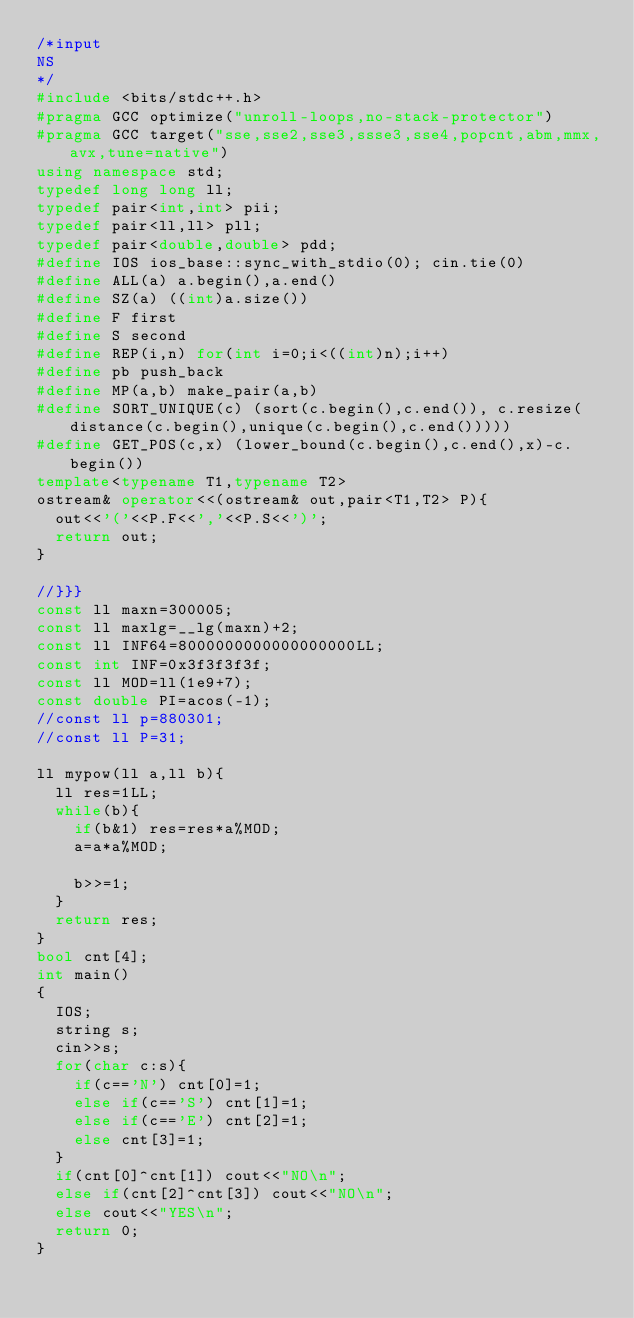Convert code to text. <code><loc_0><loc_0><loc_500><loc_500><_C++_>/*input
NS
*/
#include <bits/stdc++.h>
#pragma GCC optimize("unroll-loops,no-stack-protector")
#pragma GCC target("sse,sse2,sse3,ssse3,sse4,popcnt,abm,mmx,avx,tune=native")
using namespace std;
typedef long long ll;
typedef pair<int,int> pii;
typedef pair<ll,ll> pll;
typedef pair<double,double> pdd;
#define IOS ios_base::sync_with_stdio(0); cin.tie(0)
#define ALL(a) a.begin(),a.end()
#define SZ(a) ((int)a.size())
#define F first
#define S second
#define REP(i,n) for(int i=0;i<((int)n);i++)
#define pb push_back
#define MP(a,b) make_pair(a,b)
#define SORT_UNIQUE(c) (sort(c.begin(),c.end()), c.resize(distance(c.begin(),unique(c.begin(),c.end()))))
#define GET_POS(c,x) (lower_bound(c.begin(),c.end(),x)-c.begin())
template<typename T1,typename T2>
ostream& operator<<(ostream& out,pair<T1,T2> P){
	out<<'('<<P.F<<','<<P.S<<')';
	return out;
}

//}}}
const ll maxn=300005;
const ll maxlg=__lg(maxn)+2;
const ll INF64=8000000000000000000LL;
const int INF=0x3f3f3f3f;
const ll MOD=ll(1e9+7);
const double PI=acos(-1);
//const ll p=880301;
//const ll P=31;

ll mypow(ll a,ll b){
	ll res=1LL;
	while(b){
		if(b&1) res=res*a%MOD;
		a=a*a%MOD;
		
		b>>=1;
	}
	return res;
}
bool cnt[4];
int main()
{
	IOS;
	string s;
	cin>>s;
	for(char c:s){
		if(c=='N') cnt[0]=1;
		else if(c=='S') cnt[1]=1;
		else if(c=='E') cnt[2]=1;
		else cnt[3]=1;
	}
	if(cnt[0]^cnt[1]) cout<<"NO\n";
	else if(cnt[2]^cnt[3]) cout<<"NO\n";
	else cout<<"YES\n";
	return 0;
}
</code> 